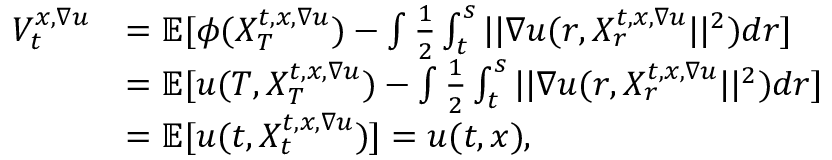<formula> <loc_0><loc_0><loc_500><loc_500>\begin{array} { r l } { V _ { t } ^ { x , \nabla u } } & { = \mathbb { E } [ \phi ( X _ { T } ^ { t , x , \nabla u } ) - \int \frac { 1 } { 2 } \int _ { t } ^ { s } | | \nabla u ( r , X _ { r } ^ { t , x , \nabla u } | | ^ { 2 } ) d r ] } \\ & { = \mathbb { E } [ u ( T , X _ { T } ^ { t , x , \nabla u } ) - \int \frac { 1 } { 2 } \int _ { t } ^ { s } | | \nabla u ( r , X _ { r } ^ { t , x , \nabla u } | | ^ { 2 } ) d r ] } \\ & { = \mathbb { E } [ u ( t , X _ { t } ^ { t , x , \nabla u } ) ] = u ( t , x ) , } \end{array}</formula> 